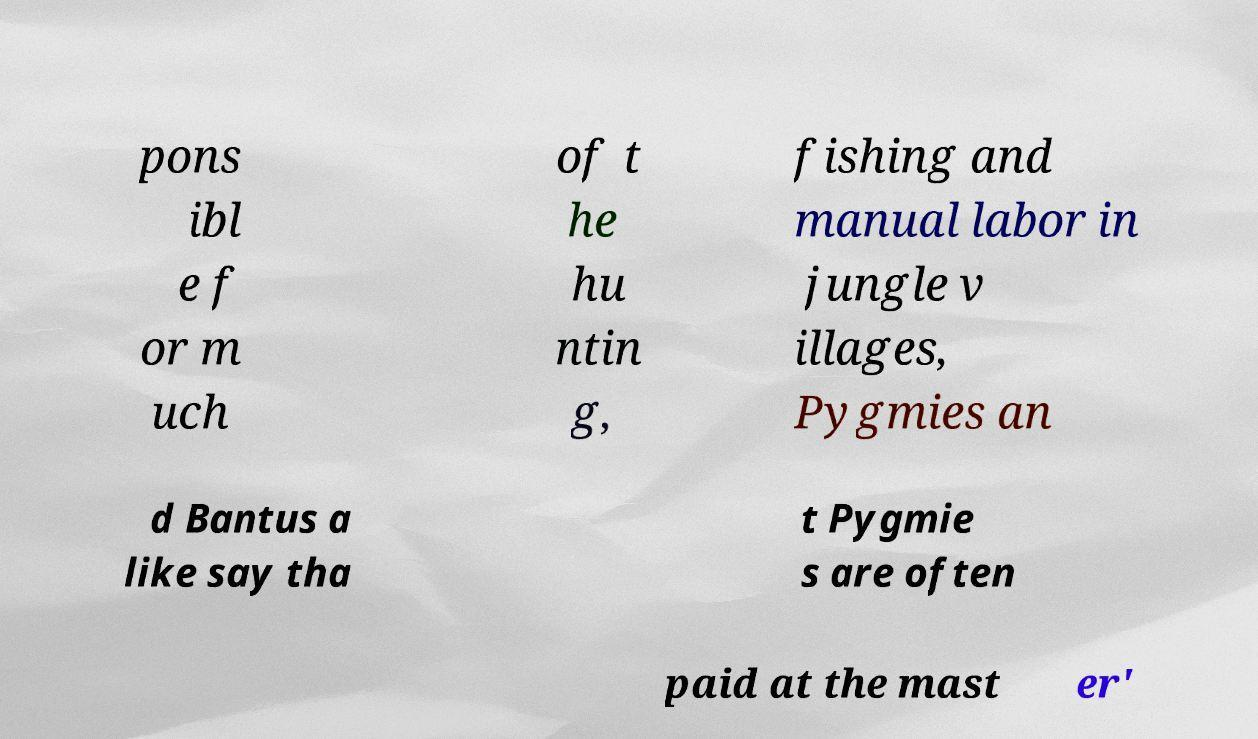Please read and relay the text visible in this image. What does it say? pons ibl e f or m uch of t he hu ntin g, fishing and manual labor in jungle v illages, Pygmies an d Bantus a like say tha t Pygmie s are often paid at the mast er' 